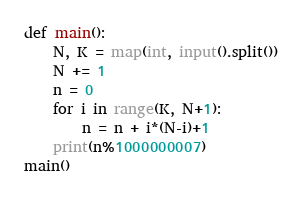Convert code to text. <code><loc_0><loc_0><loc_500><loc_500><_Python_>def main():
    N, K = map(int, input().split())
    N += 1
    n = 0
    for i in range(K, N+1):
        n = n + i*(N-i)+1
    print(n%1000000007)
main()</code> 